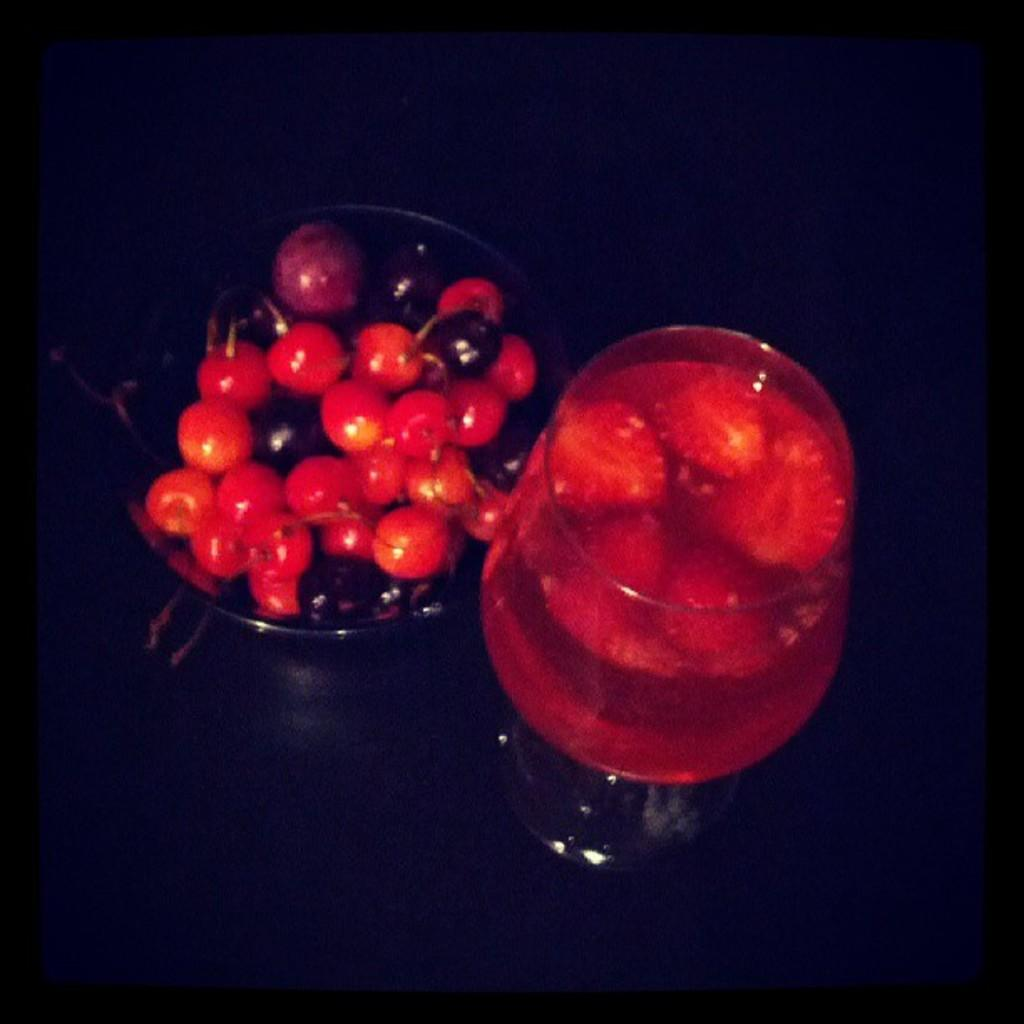What is arranged in a glass cup on the left side of the image? There are fruits arranged in a glass cup on the left side of the image. What is in the glass on the right side of the image? There is a glass filled with juice on the right side of the image. How would you describe the background of the image? The background of the image is dark in color. How many boats can be seen in the image? There are no boats present in the image. What type of can is visible in the image? There is no can present in the image. 